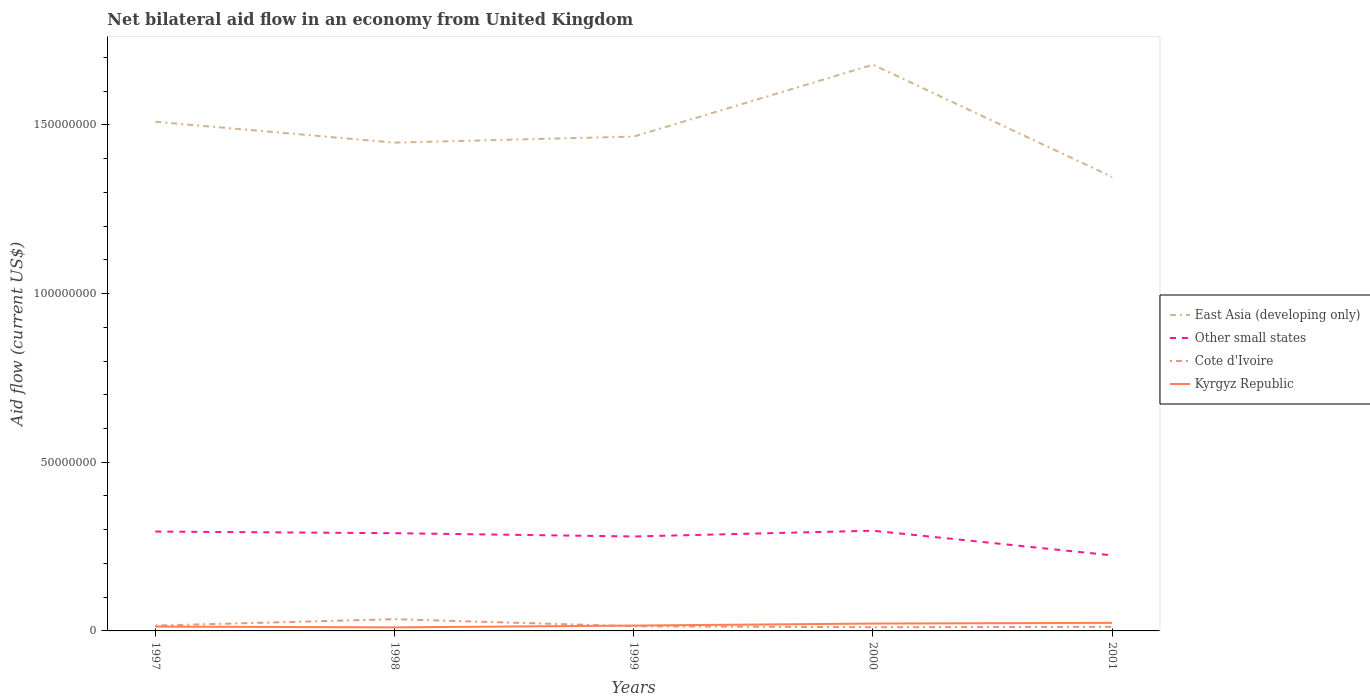Across all years, what is the maximum net bilateral aid flow in Kyrgyz Republic?
Provide a short and direct response. 1.05e+06. What is the total net bilateral aid flow in East Asia (developing only) in the graph?
Your answer should be very brief. -1.80e+06. What is the difference between the highest and the second highest net bilateral aid flow in Cote d'Ivoire?
Make the answer very short. 2.39e+06. What is the difference between the highest and the lowest net bilateral aid flow in Kyrgyz Republic?
Ensure brevity in your answer.  2. How many years are there in the graph?
Ensure brevity in your answer.  5. Does the graph contain any zero values?
Your response must be concise. No. Where does the legend appear in the graph?
Provide a succinct answer. Center right. How many legend labels are there?
Provide a short and direct response. 4. What is the title of the graph?
Give a very brief answer. Net bilateral aid flow in an economy from United Kingdom. Does "Lesotho" appear as one of the legend labels in the graph?
Ensure brevity in your answer.  No. What is the label or title of the X-axis?
Keep it short and to the point. Years. What is the label or title of the Y-axis?
Offer a very short reply. Aid flow (current US$). What is the Aid flow (current US$) in East Asia (developing only) in 1997?
Your response must be concise. 1.51e+08. What is the Aid flow (current US$) in Other small states in 1997?
Offer a terse response. 2.95e+07. What is the Aid flow (current US$) in Cote d'Ivoire in 1997?
Keep it short and to the point. 1.58e+06. What is the Aid flow (current US$) in Kyrgyz Republic in 1997?
Keep it short and to the point. 1.29e+06. What is the Aid flow (current US$) of East Asia (developing only) in 1998?
Offer a terse response. 1.45e+08. What is the Aid flow (current US$) in Other small states in 1998?
Your answer should be very brief. 2.90e+07. What is the Aid flow (current US$) of Cote d'Ivoire in 1998?
Make the answer very short. 3.48e+06. What is the Aid flow (current US$) in Kyrgyz Republic in 1998?
Keep it short and to the point. 1.05e+06. What is the Aid flow (current US$) in East Asia (developing only) in 1999?
Provide a short and direct response. 1.47e+08. What is the Aid flow (current US$) of Other small states in 1999?
Offer a terse response. 2.80e+07. What is the Aid flow (current US$) of Cote d'Ivoire in 1999?
Provide a short and direct response. 1.39e+06. What is the Aid flow (current US$) in Kyrgyz Republic in 1999?
Offer a terse response. 1.59e+06. What is the Aid flow (current US$) of East Asia (developing only) in 2000?
Your answer should be very brief. 1.68e+08. What is the Aid flow (current US$) in Other small states in 2000?
Give a very brief answer. 2.97e+07. What is the Aid flow (current US$) in Cote d'Ivoire in 2000?
Offer a very short reply. 1.09e+06. What is the Aid flow (current US$) of Kyrgyz Republic in 2000?
Offer a terse response. 2.18e+06. What is the Aid flow (current US$) in East Asia (developing only) in 2001?
Ensure brevity in your answer.  1.35e+08. What is the Aid flow (current US$) of Other small states in 2001?
Your answer should be very brief. 2.24e+07. What is the Aid flow (current US$) of Cote d'Ivoire in 2001?
Give a very brief answer. 1.21e+06. What is the Aid flow (current US$) in Kyrgyz Republic in 2001?
Provide a succinct answer. 2.39e+06. Across all years, what is the maximum Aid flow (current US$) of East Asia (developing only)?
Make the answer very short. 1.68e+08. Across all years, what is the maximum Aid flow (current US$) in Other small states?
Keep it short and to the point. 2.97e+07. Across all years, what is the maximum Aid flow (current US$) in Cote d'Ivoire?
Make the answer very short. 3.48e+06. Across all years, what is the maximum Aid flow (current US$) in Kyrgyz Republic?
Keep it short and to the point. 2.39e+06. Across all years, what is the minimum Aid flow (current US$) of East Asia (developing only)?
Your response must be concise. 1.35e+08. Across all years, what is the minimum Aid flow (current US$) of Other small states?
Offer a terse response. 2.24e+07. Across all years, what is the minimum Aid flow (current US$) of Cote d'Ivoire?
Give a very brief answer. 1.09e+06. Across all years, what is the minimum Aid flow (current US$) of Kyrgyz Republic?
Provide a short and direct response. 1.05e+06. What is the total Aid flow (current US$) in East Asia (developing only) in the graph?
Provide a short and direct response. 7.45e+08. What is the total Aid flow (current US$) of Other small states in the graph?
Make the answer very short. 1.39e+08. What is the total Aid flow (current US$) in Cote d'Ivoire in the graph?
Offer a terse response. 8.75e+06. What is the total Aid flow (current US$) in Kyrgyz Republic in the graph?
Ensure brevity in your answer.  8.50e+06. What is the difference between the Aid flow (current US$) of East Asia (developing only) in 1997 and that in 1998?
Your answer should be compact. 6.19e+06. What is the difference between the Aid flow (current US$) of Other small states in 1997 and that in 1998?
Provide a short and direct response. 4.90e+05. What is the difference between the Aid flow (current US$) of Cote d'Ivoire in 1997 and that in 1998?
Offer a terse response. -1.90e+06. What is the difference between the Aid flow (current US$) in East Asia (developing only) in 1997 and that in 1999?
Give a very brief answer. 4.39e+06. What is the difference between the Aid flow (current US$) of Other small states in 1997 and that in 1999?
Offer a very short reply. 1.46e+06. What is the difference between the Aid flow (current US$) of Cote d'Ivoire in 1997 and that in 1999?
Provide a succinct answer. 1.90e+05. What is the difference between the Aid flow (current US$) in East Asia (developing only) in 1997 and that in 2000?
Make the answer very short. -1.69e+07. What is the difference between the Aid flow (current US$) of Kyrgyz Republic in 1997 and that in 2000?
Offer a very short reply. -8.90e+05. What is the difference between the Aid flow (current US$) of East Asia (developing only) in 1997 and that in 2001?
Make the answer very short. 1.64e+07. What is the difference between the Aid flow (current US$) in Other small states in 1997 and that in 2001?
Provide a short and direct response. 7.06e+06. What is the difference between the Aid flow (current US$) of Kyrgyz Republic in 1997 and that in 2001?
Offer a very short reply. -1.10e+06. What is the difference between the Aid flow (current US$) of East Asia (developing only) in 1998 and that in 1999?
Provide a succinct answer. -1.80e+06. What is the difference between the Aid flow (current US$) in Other small states in 1998 and that in 1999?
Your answer should be compact. 9.70e+05. What is the difference between the Aid flow (current US$) of Cote d'Ivoire in 1998 and that in 1999?
Provide a short and direct response. 2.09e+06. What is the difference between the Aid flow (current US$) of Kyrgyz Republic in 1998 and that in 1999?
Provide a succinct answer. -5.40e+05. What is the difference between the Aid flow (current US$) in East Asia (developing only) in 1998 and that in 2000?
Ensure brevity in your answer.  -2.31e+07. What is the difference between the Aid flow (current US$) of Other small states in 1998 and that in 2000?
Provide a short and direct response. -7.40e+05. What is the difference between the Aid flow (current US$) in Cote d'Ivoire in 1998 and that in 2000?
Keep it short and to the point. 2.39e+06. What is the difference between the Aid flow (current US$) of Kyrgyz Republic in 1998 and that in 2000?
Make the answer very short. -1.13e+06. What is the difference between the Aid flow (current US$) in East Asia (developing only) in 1998 and that in 2001?
Make the answer very short. 1.02e+07. What is the difference between the Aid flow (current US$) of Other small states in 1998 and that in 2001?
Keep it short and to the point. 6.57e+06. What is the difference between the Aid flow (current US$) in Cote d'Ivoire in 1998 and that in 2001?
Keep it short and to the point. 2.27e+06. What is the difference between the Aid flow (current US$) of Kyrgyz Republic in 1998 and that in 2001?
Provide a short and direct response. -1.34e+06. What is the difference between the Aid flow (current US$) of East Asia (developing only) in 1999 and that in 2000?
Offer a very short reply. -2.13e+07. What is the difference between the Aid flow (current US$) of Other small states in 1999 and that in 2000?
Provide a succinct answer. -1.71e+06. What is the difference between the Aid flow (current US$) in Kyrgyz Republic in 1999 and that in 2000?
Make the answer very short. -5.90e+05. What is the difference between the Aid flow (current US$) in East Asia (developing only) in 1999 and that in 2001?
Keep it short and to the point. 1.20e+07. What is the difference between the Aid flow (current US$) in Other small states in 1999 and that in 2001?
Ensure brevity in your answer.  5.60e+06. What is the difference between the Aid flow (current US$) in Cote d'Ivoire in 1999 and that in 2001?
Offer a very short reply. 1.80e+05. What is the difference between the Aid flow (current US$) of Kyrgyz Republic in 1999 and that in 2001?
Give a very brief answer. -8.00e+05. What is the difference between the Aid flow (current US$) of East Asia (developing only) in 2000 and that in 2001?
Ensure brevity in your answer.  3.33e+07. What is the difference between the Aid flow (current US$) in Other small states in 2000 and that in 2001?
Offer a terse response. 7.31e+06. What is the difference between the Aid flow (current US$) of Kyrgyz Republic in 2000 and that in 2001?
Ensure brevity in your answer.  -2.10e+05. What is the difference between the Aid flow (current US$) in East Asia (developing only) in 1997 and the Aid flow (current US$) in Other small states in 1998?
Provide a succinct answer. 1.22e+08. What is the difference between the Aid flow (current US$) in East Asia (developing only) in 1997 and the Aid flow (current US$) in Cote d'Ivoire in 1998?
Your response must be concise. 1.47e+08. What is the difference between the Aid flow (current US$) in East Asia (developing only) in 1997 and the Aid flow (current US$) in Kyrgyz Republic in 1998?
Provide a short and direct response. 1.50e+08. What is the difference between the Aid flow (current US$) of Other small states in 1997 and the Aid flow (current US$) of Cote d'Ivoire in 1998?
Keep it short and to the point. 2.60e+07. What is the difference between the Aid flow (current US$) in Other small states in 1997 and the Aid flow (current US$) in Kyrgyz Republic in 1998?
Offer a terse response. 2.84e+07. What is the difference between the Aid flow (current US$) of Cote d'Ivoire in 1997 and the Aid flow (current US$) of Kyrgyz Republic in 1998?
Give a very brief answer. 5.30e+05. What is the difference between the Aid flow (current US$) of East Asia (developing only) in 1997 and the Aid flow (current US$) of Other small states in 1999?
Keep it short and to the point. 1.23e+08. What is the difference between the Aid flow (current US$) of East Asia (developing only) in 1997 and the Aid flow (current US$) of Cote d'Ivoire in 1999?
Provide a short and direct response. 1.50e+08. What is the difference between the Aid flow (current US$) in East Asia (developing only) in 1997 and the Aid flow (current US$) in Kyrgyz Republic in 1999?
Your answer should be very brief. 1.49e+08. What is the difference between the Aid flow (current US$) of Other small states in 1997 and the Aid flow (current US$) of Cote d'Ivoire in 1999?
Your answer should be very brief. 2.81e+07. What is the difference between the Aid flow (current US$) of Other small states in 1997 and the Aid flow (current US$) of Kyrgyz Republic in 1999?
Offer a very short reply. 2.79e+07. What is the difference between the Aid flow (current US$) of East Asia (developing only) in 1997 and the Aid flow (current US$) of Other small states in 2000?
Offer a terse response. 1.21e+08. What is the difference between the Aid flow (current US$) in East Asia (developing only) in 1997 and the Aid flow (current US$) in Cote d'Ivoire in 2000?
Your response must be concise. 1.50e+08. What is the difference between the Aid flow (current US$) in East Asia (developing only) in 1997 and the Aid flow (current US$) in Kyrgyz Republic in 2000?
Ensure brevity in your answer.  1.49e+08. What is the difference between the Aid flow (current US$) of Other small states in 1997 and the Aid flow (current US$) of Cote d'Ivoire in 2000?
Your response must be concise. 2.84e+07. What is the difference between the Aid flow (current US$) of Other small states in 1997 and the Aid flow (current US$) of Kyrgyz Republic in 2000?
Provide a succinct answer. 2.73e+07. What is the difference between the Aid flow (current US$) of Cote d'Ivoire in 1997 and the Aid flow (current US$) of Kyrgyz Republic in 2000?
Keep it short and to the point. -6.00e+05. What is the difference between the Aid flow (current US$) of East Asia (developing only) in 1997 and the Aid flow (current US$) of Other small states in 2001?
Keep it short and to the point. 1.29e+08. What is the difference between the Aid flow (current US$) in East Asia (developing only) in 1997 and the Aid flow (current US$) in Cote d'Ivoire in 2001?
Provide a short and direct response. 1.50e+08. What is the difference between the Aid flow (current US$) in East Asia (developing only) in 1997 and the Aid flow (current US$) in Kyrgyz Republic in 2001?
Keep it short and to the point. 1.49e+08. What is the difference between the Aid flow (current US$) of Other small states in 1997 and the Aid flow (current US$) of Cote d'Ivoire in 2001?
Your answer should be compact. 2.82e+07. What is the difference between the Aid flow (current US$) of Other small states in 1997 and the Aid flow (current US$) of Kyrgyz Republic in 2001?
Offer a very short reply. 2.71e+07. What is the difference between the Aid flow (current US$) in Cote d'Ivoire in 1997 and the Aid flow (current US$) in Kyrgyz Republic in 2001?
Keep it short and to the point. -8.10e+05. What is the difference between the Aid flow (current US$) in East Asia (developing only) in 1998 and the Aid flow (current US$) in Other small states in 1999?
Offer a very short reply. 1.17e+08. What is the difference between the Aid flow (current US$) in East Asia (developing only) in 1998 and the Aid flow (current US$) in Cote d'Ivoire in 1999?
Your answer should be compact. 1.43e+08. What is the difference between the Aid flow (current US$) in East Asia (developing only) in 1998 and the Aid flow (current US$) in Kyrgyz Republic in 1999?
Your answer should be very brief. 1.43e+08. What is the difference between the Aid flow (current US$) in Other small states in 1998 and the Aid flow (current US$) in Cote d'Ivoire in 1999?
Offer a very short reply. 2.76e+07. What is the difference between the Aid flow (current US$) in Other small states in 1998 and the Aid flow (current US$) in Kyrgyz Republic in 1999?
Give a very brief answer. 2.74e+07. What is the difference between the Aid flow (current US$) in Cote d'Ivoire in 1998 and the Aid flow (current US$) in Kyrgyz Republic in 1999?
Offer a terse response. 1.89e+06. What is the difference between the Aid flow (current US$) of East Asia (developing only) in 1998 and the Aid flow (current US$) of Other small states in 2000?
Provide a succinct answer. 1.15e+08. What is the difference between the Aid flow (current US$) in East Asia (developing only) in 1998 and the Aid flow (current US$) in Cote d'Ivoire in 2000?
Keep it short and to the point. 1.44e+08. What is the difference between the Aid flow (current US$) of East Asia (developing only) in 1998 and the Aid flow (current US$) of Kyrgyz Republic in 2000?
Give a very brief answer. 1.43e+08. What is the difference between the Aid flow (current US$) in Other small states in 1998 and the Aid flow (current US$) in Cote d'Ivoire in 2000?
Give a very brief answer. 2.79e+07. What is the difference between the Aid flow (current US$) in Other small states in 1998 and the Aid flow (current US$) in Kyrgyz Republic in 2000?
Your answer should be very brief. 2.68e+07. What is the difference between the Aid flow (current US$) in Cote d'Ivoire in 1998 and the Aid flow (current US$) in Kyrgyz Republic in 2000?
Your answer should be very brief. 1.30e+06. What is the difference between the Aid flow (current US$) in East Asia (developing only) in 1998 and the Aid flow (current US$) in Other small states in 2001?
Make the answer very short. 1.22e+08. What is the difference between the Aid flow (current US$) in East Asia (developing only) in 1998 and the Aid flow (current US$) in Cote d'Ivoire in 2001?
Keep it short and to the point. 1.44e+08. What is the difference between the Aid flow (current US$) in East Asia (developing only) in 1998 and the Aid flow (current US$) in Kyrgyz Republic in 2001?
Ensure brevity in your answer.  1.42e+08. What is the difference between the Aid flow (current US$) in Other small states in 1998 and the Aid flow (current US$) in Cote d'Ivoire in 2001?
Offer a terse response. 2.78e+07. What is the difference between the Aid flow (current US$) in Other small states in 1998 and the Aid flow (current US$) in Kyrgyz Republic in 2001?
Your answer should be very brief. 2.66e+07. What is the difference between the Aid flow (current US$) in Cote d'Ivoire in 1998 and the Aid flow (current US$) in Kyrgyz Republic in 2001?
Your answer should be very brief. 1.09e+06. What is the difference between the Aid flow (current US$) in East Asia (developing only) in 1999 and the Aid flow (current US$) in Other small states in 2000?
Your answer should be very brief. 1.17e+08. What is the difference between the Aid flow (current US$) of East Asia (developing only) in 1999 and the Aid flow (current US$) of Cote d'Ivoire in 2000?
Give a very brief answer. 1.45e+08. What is the difference between the Aid flow (current US$) in East Asia (developing only) in 1999 and the Aid flow (current US$) in Kyrgyz Republic in 2000?
Your answer should be very brief. 1.44e+08. What is the difference between the Aid flow (current US$) of Other small states in 1999 and the Aid flow (current US$) of Cote d'Ivoire in 2000?
Your answer should be compact. 2.69e+07. What is the difference between the Aid flow (current US$) of Other small states in 1999 and the Aid flow (current US$) of Kyrgyz Republic in 2000?
Offer a terse response. 2.58e+07. What is the difference between the Aid flow (current US$) in Cote d'Ivoire in 1999 and the Aid flow (current US$) in Kyrgyz Republic in 2000?
Provide a succinct answer. -7.90e+05. What is the difference between the Aid flow (current US$) in East Asia (developing only) in 1999 and the Aid flow (current US$) in Other small states in 2001?
Ensure brevity in your answer.  1.24e+08. What is the difference between the Aid flow (current US$) of East Asia (developing only) in 1999 and the Aid flow (current US$) of Cote d'Ivoire in 2001?
Your response must be concise. 1.45e+08. What is the difference between the Aid flow (current US$) of East Asia (developing only) in 1999 and the Aid flow (current US$) of Kyrgyz Republic in 2001?
Keep it short and to the point. 1.44e+08. What is the difference between the Aid flow (current US$) of Other small states in 1999 and the Aid flow (current US$) of Cote d'Ivoire in 2001?
Your answer should be very brief. 2.68e+07. What is the difference between the Aid flow (current US$) of Other small states in 1999 and the Aid flow (current US$) of Kyrgyz Republic in 2001?
Make the answer very short. 2.56e+07. What is the difference between the Aid flow (current US$) of East Asia (developing only) in 2000 and the Aid flow (current US$) of Other small states in 2001?
Ensure brevity in your answer.  1.45e+08. What is the difference between the Aid flow (current US$) in East Asia (developing only) in 2000 and the Aid flow (current US$) in Cote d'Ivoire in 2001?
Make the answer very short. 1.67e+08. What is the difference between the Aid flow (current US$) in East Asia (developing only) in 2000 and the Aid flow (current US$) in Kyrgyz Republic in 2001?
Your answer should be compact. 1.65e+08. What is the difference between the Aid flow (current US$) in Other small states in 2000 and the Aid flow (current US$) in Cote d'Ivoire in 2001?
Ensure brevity in your answer.  2.85e+07. What is the difference between the Aid flow (current US$) of Other small states in 2000 and the Aid flow (current US$) of Kyrgyz Republic in 2001?
Provide a short and direct response. 2.73e+07. What is the difference between the Aid flow (current US$) of Cote d'Ivoire in 2000 and the Aid flow (current US$) of Kyrgyz Republic in 2001?
Provide a succinct answer. -1.30e+06. What is the average Aid flow (current US$) in East Asia (developing only) per year?
Your response must be concise. 1.49e+08. What is the average Aid flow (current US$) in Other small states per year?
Keep it short and to the point. 2.77e+07. What is the average Aid flow (current US$) of Cote d'Ivoire per year?
Provide a short and direct response. 1.75e+06. What is the average Aid flow (current US$) in Kyrgyz Republic per year?
Provide a succinct answer. 1.70e+06. In the year 1997, what is the difference between the Aid flow (current US$) in East Asia (developing only) and Aid flow (current US$) in Other small states?
Provide a succinct answer. 1.21e+08. In the year 1997, what is the difference between the Aid flow (current US$) of East Asia (developing only) and Aid flow (current US$) of Cote d'Ivoire?
Ensure brevity in your answer.  1.49e+08. In the year 1997, what is the difference between the Aid flow (current US$) in East Asia (developing only) and Aid flow (current US$) in Kyrgyz Republic?
Make the answer very short. 1.50e+08. In the year 1997, what is the difference between the Aid flow (current US$) of Other small states and Aid flow (current US$) of Cote d'Ivoire?
Make the answer very short. 2.79e+07. In the year 1997, what is the difference between the Aid flow (current US$) in Other small states and Aid flow (current US$) in Kyrgyz Republic?
Offer a terse response. 2.82e+07. In the year 1998, what is the difference between the Aid flow (current US$) of East Asia (developing only) and Aid flow (current US$) of Other small states?
Give a very brief answer. 1.16e+08. In the year 1998, what is the difference between the Aid flow (current US$) in East Asia (developing only) and Aid flow (current US$) in Cote d'Ivoire?
Provide a succinct answer. 1.41e+08. In the year 1998, what is the difference between the Aid flow (current US$) in East Asia (developing only) and Aid flow (current US$) in Kyrgyz Republic?
Offer a terse response. 1.44e+08. In the year 1998, what is the difference between the Aid flow (current US$) of Other small states and Aid flow (current US$) of Cote d'Ivoire?
Your answer should be very brief. 2.55e+07. In the year 1998, what is the difference between the Aid flow (current US$) of Other small states and Aid flow (current US$) of Kyrgyz Republic?
Your answer should be compact. 2.79e+07. In the year 1998, what is the difference between the Aid flow (current US$) in Cote d'Ivoire and Aid flow (current US$) in Kyrgyz Republic?
Give a very brief answer. 2.43e+06. In the year 1999, what is the difference between the Aid flow (current US$) of East Asia (developing only) and Aid flow (current US$) of Other small states?
Ensure brevity in your answer.  1.19e+08. In the year 1999, what is the difference between the Aid flow (current US$) of East Asia (developing only) and Aid flow (current US$) of Cote d'Ivoire?
Provide a short and direct response. 1.45e+08. In the year 1999, what is the difference between the Aid flow (current US$) of East Asia (developing only) and Aid flow (current US$) of Kyrgyz Republic?
Provide a short and direct response. 1.45e+08. In the year 1999, what is the difference between the Aid flow (current US$) of Other small states and Aid flow (current US$) of Cote d'Ivoire?
Keep it short and to the point. 2.66e+07. In the year 1999, what is the difference between the Aid flow (current US$) in Other small states and Aid flow (current US$) in Kyrgyz Republic?
Your answer should be very brief. 2.64e+07. In the year 1999, what is the difference between the Aid flow (current US$) in Cote d'Ivoire and Aid flow (current US$) in Kyrgyz Republic?
Your answer should be very brief. -2.00e+05. In the year 2000, what is the difference between the Aid flow (current US$) in East Asia (developing only) and Aid flow (current US$) in Other small states?
Make the answer very short. 1.38e+08. In the year 2000, what is the difference between the Aid flow (current US$) of East Asia (developing only) and Aid flow (current US$) of Cote d'Ivoire?
Provide a short and direct response. 1.67e+08. In the year 2000, what is the difference between the Aid flow (current US$) of East Asia (developing only) and Aid flow (current US$) of Kyrgyz Republic?
Keep it short and to the point. 1.66e+08. In the year 2000, what is the difference between the Aid flow (current US$) of Other small states and Aid flow (current US$) of Cote d'Ivoire?
Provide a succinct answer. 2.86e+07. In the year 2000, what is the difference between the Aid flow (current US$) of Other small states and Aid flow (current US$) of Kyrgyz Republic?
Provide a short and direct response. 2.75e+07. In the year 2000, what is the difference between the Aid flow (current US$) of Cote d'Ivoire and Aid flow (current US$) of Kyrgyz Republic?
Keep it short and to the point. -1.09e+06. In the year 2001, what is the difference between the Aid flow (current US$) in East Asia (developing only) and Aid flow (current US$) in Other small states?
Give a very brief answer. 1.12e+08. In the year 2001, what is the difference between the Aid flow (current US$) of East Asia (developing only) and Aid flow (current US$) of Cote d'Ivoire?
Provide a short and direct response. 1.33e+08. In the year 2001, what is the difference between the Aid flow (current US$) in East Asia (developing only) and Aid flow (current US$) in Kyrgyz Republic?
Provide a short and direct response. 1.32e+08. In the year 2001, what is the difference between the Aid flow (current US$) in Other small states and Aid flow (current US$) in Cote d'Ivoire?
Your answer should be very brief. 2.12e+07. In the year 2001, what is the difference between the Aid flow (current US$) of Other small states and Aid flow (current US$) of Kyrgyz Republic?
Give a very brief answer. 2.00e+07. In the year 2001, what is the difference between the Aid flow (current US$) of Cote d'Ivoire and Aid flow (current US$) of Kyrgyz Republic?
Offer a very short reply. -1.18e+06. What is the ratio of the Aid flow (current US$) in East Asia (developing only) in 1997 to that in 1998?
Your answer should be very brief. 1.04. What is the ratio of the Aid flow (current US$) of Other small states in 1997 to that in 1998?
Make the answer very short. 1.02. What is the ratio of the Aid flow (current US$) of Cote d'Ivoire in 1997 to that in 1998?
Ensure brevity in your answer.  0.45. What is the ratio of the Aid flow (current US$) of Kyrgyz Republic in 1997 to that in 1998?
Offer a very short reply. 1.23. What is the ratio of the Aid flow (current US$) in East Asia (developing only) in 1997 to that in 1999?
Provide a short and direct response. 1.03. What is the ratio of the Aid flow (current US$) in Other small states in 1997 to that in 1999?
Your answer should be compact. 1.05. What is the ratio of the Aid flow (current US$) of Cote d'Ivoire in 1997 to that in 1999?
Offer a very short reply. 1.14. What is the ratio of the Aid flow (current US$) of Kyrgyz Republic in 1997 to that in 1999?
Offer a very short reply. 0.81. What is the ratio of the Aid flow (current US$) in East Asia (developing only) in 1997 to that in 2000?
Make the answer very short. 0.9. What is the ratio of the Aid flow (current US$) of Other small states in 1997 to that in 2000?
Offer a very short reply. 0.99. What is the ratio of the Aid flow (current US$) of Cote d'Ivoire in 1997 to that in 2000?
Offer a terse response. 1.45. What is the ratio of the Aid flow (current US$) of Kyrgyz Republic in 1997 to that in 2000?
Offer a very short reply. 0.59. What is the ratio of the Aid flow (current US$) in East Asia (developing only) in 1997 to that in 2001?
Your answer should be compact. 1.12. What is the ratio of the Aid flow (current US$) of Other small states in 1997 to that in 2001?
Provide a succinct answer. 1.32. What is the ratio of the Aid flow (current US$) of Cote d'Ivoire in 1997 to that in 2001?
Your response must be concise. 1.31. What is the ratio of the Aid flow (current US$) in Kyrgyz Republic in 1997 to that in 2001?
Offer a terse response. 0.54. What is the ratio of the Aid flow (current US$) in Other small states in 1998 to that in 1999?
Offer a terse response. 1.03. What is the ratio of the Aid flow (current US$) of Cote d'Ivoire in 1998 to that in 1999?
Provide a short and direct response. 2.5. What is the ratio of the Aid flow (current US$) of Kyrgyz Republic in 1998 to that in 1999?
Your answer should be compact. 0.66. What is the ratio of the Aid flow (current US$) of East Asia (developing only) in 1998 to that in 2000?
Provide a short and direct response. 0.86. What is the ratio of the Aid flow (current US$) in Other small states in 1998 to that in 2000?
Offer a very short reply. 0.98. What is the ratio of the Aid flow (current US$) in Cote d'Ivoire in 1998 to that in 2000?
Your response must be concise. 3.19. What is the ratio of the Aid flow (current US$) in Kyrgyz Republic in 1998 to that in 2000?
Give a very brief answer. 0.48. What is the ratio of the Aid flow (current US$) of East Asia (developing only) in 1998 to that in 2001?
Give a very brief answer. 1.08. What is the ratio of the Aid flow (current US$) in Other small states in 1998 to that in 2001?
Your response must be concise. 1.29. What is the ratio of the Aid flow (current US$) in Cote d'Ivoire in 1998 to that in 2001?
Keep it short and to the point. 2.88. What is the ratio of the Aid flow (current US$) in Kyrgyz Republic in 1998 to that in 2001?
Keep it short and to the point. 0.44. What is the ratio of the Aid flow (current US$) of East Asia (developing only) in 1999 to that in 2000?
Offer a very short reply. 0.87. What is the ratio of the Aid flow (current US$) in Other small states in 1999 to that in 2000?
Make the answer very short. 0.94. What is the ratio of the Aid flow (current US$) in Cote d'Ivoire in 1999 to that in 2000?
Offer a very short reply. 1.28. What is the ratio of the Aid flow (current US$) of Kyrgyz Republic in 1999 to that in 2000?
Your response must be concise. 0.73. What is the ratio of the Aid flow (current US$) in East Asia (developing only) in 1999 to that in 2001?
Offer a terse response. 1.09. What is the ratio of the Aid flow (current US$) in Other small states in 1999 to that in 2001?
Offer a terse response. 1.25. What is the ratio of the Aid flow (current US$) in Cote d'Ivoire in 1999 to that in 2001?
Your response must be concise. 1.15. What is the ratio of the Aid flow (current US$) in Kyrgyz Republic in 1999 to that in 2001?
Give a very brief answer. 0.67. What is the ratio of the Aid flow (current US$) of East Asia (developing only) in 2000 to that in 2001?
Make the answer very short. 1.25. What is the ratio of the Aid flow (current US$) in Other small states in 2000 to that in 2001?
Your answer should be very brief. 1.33. What is the ratio of the Aid flow (current US$) in Cote d'Ivoire in 2000 to that in 2001?
Offer a terse response. 0.9. What is the ratio of the Aid flow (current US$) of Kyrgyz Republic in 2000 to that in 2001?
Your answer should be very brief. 0.91. What is the difference between the highest and the second highest Aid flow (current US$) of East Asia (developing only)?
Keep it short and to the point. 1.69e+07. What is the difference between the highest and the second highest Aid flow (current US$) in Cote d'Ivoire?
Your answer should be very brief. 1.90e+06. What is the difference between the highest and the lowest Aid flow (current US$) of East Asia (developing only)?
Make the answer very short. 3.33e+07. What is the difference between the highest and the lowest Aid flow (current US$) in Other small states?
Provide a succinct answer. 7.31e+06. What is the difference between the highest and the lowest Aid flow (current US$) of Cote d'Ivoire?
Provide a short and direct response. 2.39e+06. What is the difference between the highest and the lowest Aid flow (current US$) of Kyrgyz Republic?
Your answer should be very brief. 1.34e+06. 